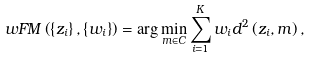<formula> <loc_0><loc_0><loc_500><loc_500>w F M \left ( \left \{ z _ { i } \right \} , \left \{ w _ { i } \right \} \right ) = \arg \min _ { m \in C } \sum _ { i = 1 } ^ { K } w _ { i } d ^ { 2 } \left ( z _ { i } , m \right ) ,</formula> 